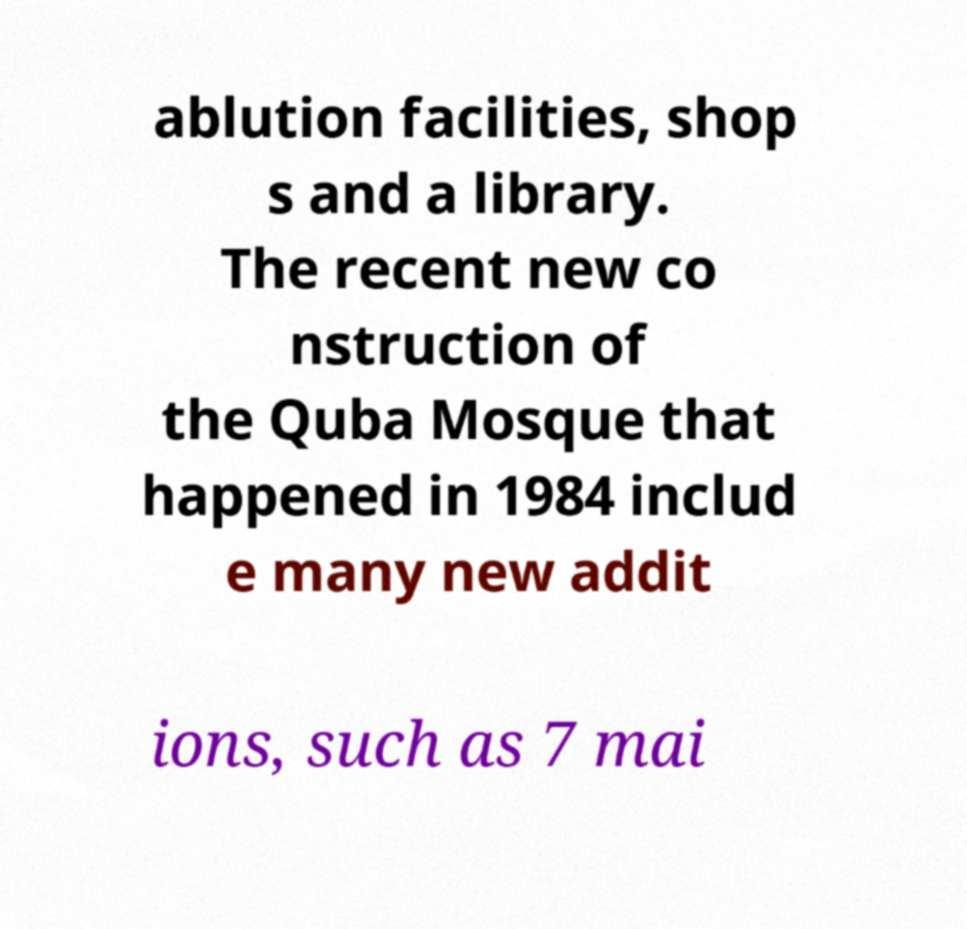What messages or text are displayed in this image? I need them in a readable, typed format. ablution facilities, shop s and a library. The recent new co nstruction of the Quba Mosque that happened in 1984 includ e many new addit ions, such as 7 mai 